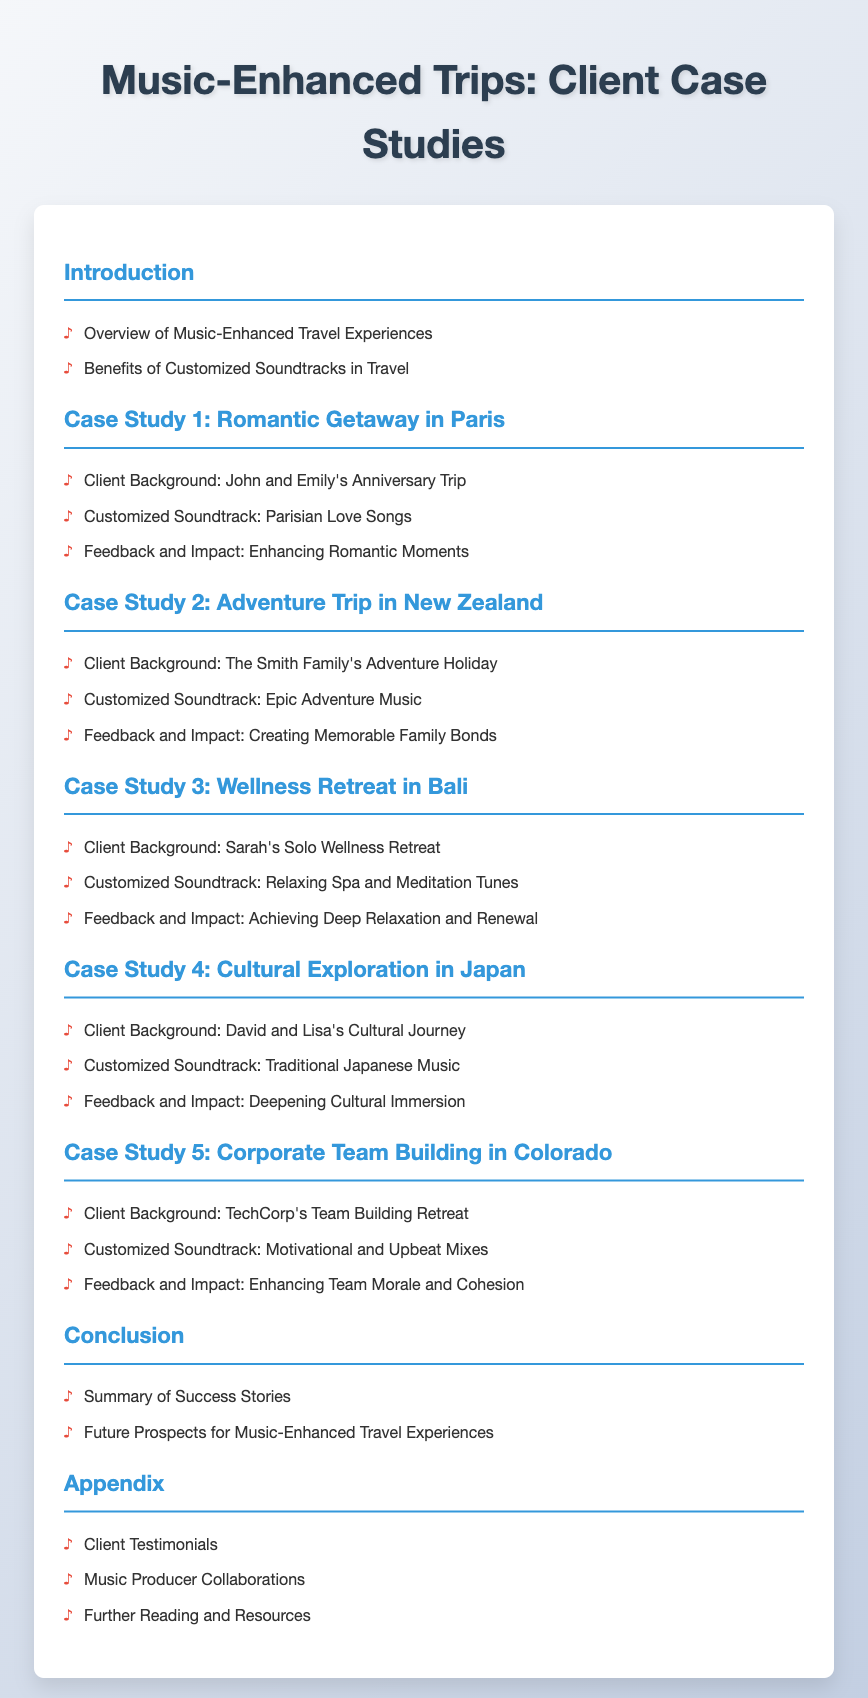What is the title of the document? The title is specified in the document header.
Answer: Music-Enhanced Trips: Client Case Studies How many case studies are presented in the document? The document lists multiple sections, each beginning with "Case Study".
Answer: Five What is the focus of Case Study 3? The title of Case Study 3 indicates its focus.
Answer: Wellness Retreat in Bali Which city is associated with the romantic getaway in Case Study 1? The client background states the location of the trip in Case Study 1.
Answer: Paris What type of music is featured in Case Study 2? The customized soundtrack for the adventure trip is described in Case Study 2.
Answer: Epic Adventure Music What benefit of customized soundtracks is mentioned in the introduction? The introduction provides two benefits of music-enhanced travel experiences.
Answer: Enhancing travel experiences What type of client is highlighted in Case Study 5? The client background details the name of the organization involved.
Answer: TechCorp What are the last two items listed in the appendix? The appendix section includes several details ending with specific topics.
Answer: Music Producer Collaborations, Further Reading and Resources What is the overall theme of the case studies? The overarching theme is indicated in the title of the document.
Answer: Music-Enhanced Travel Experiences 